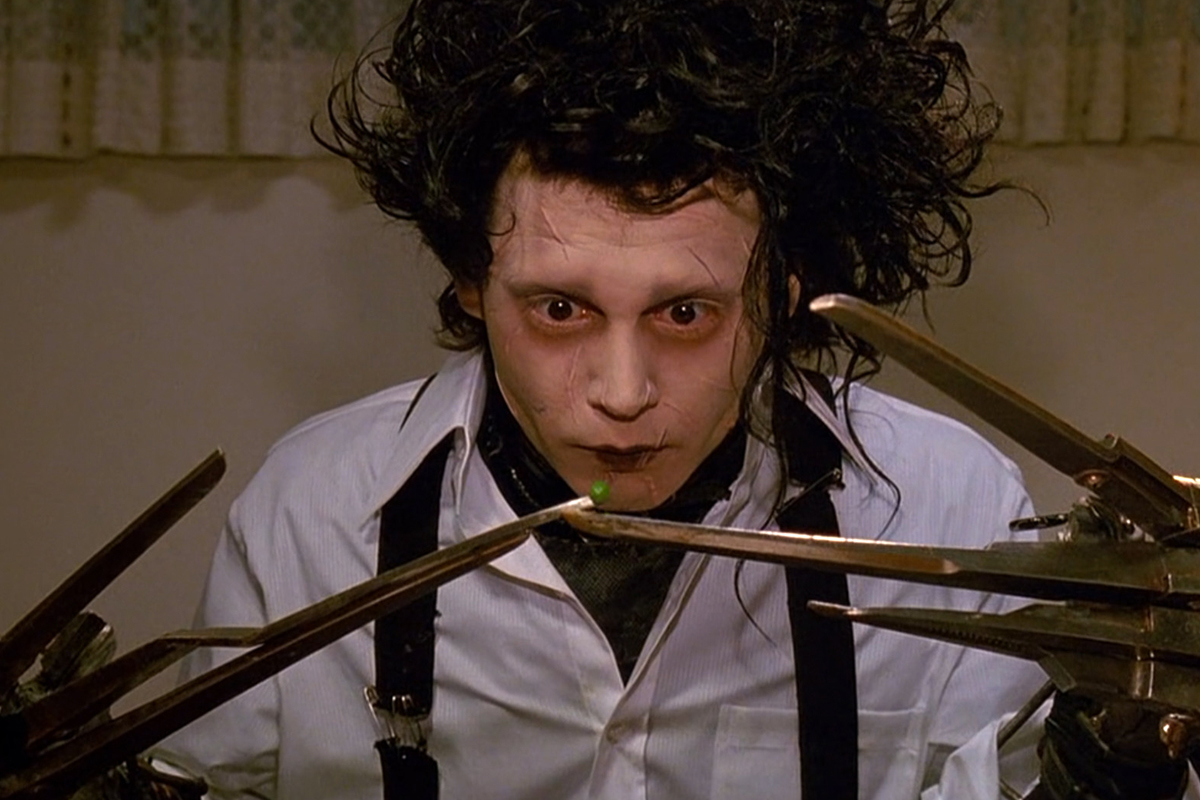What kind of fantastical world could Edward be placed into, and how would his character fit into it? Imagine Edward Scissorhands in an enchanted forest where every tree and plant is a living, breathing entity with its own personality. In this world, Edward's scissor hands would be seen as a magical gift, allowing him to communicate with the flora by trimming and shaping them into new, wondrous forms. The forest creatures would regard him as a revered caretaker, entrusting him with the task of maintaining their home. His once burdensome hands would become a source of admiration and respect, turning his solitude into a celebrated uniqueness. Edward's gentle nature and innate creativity would flourish in this fantastical environment, allowing him to form meaningful connections with the sentient beings of the forest. 